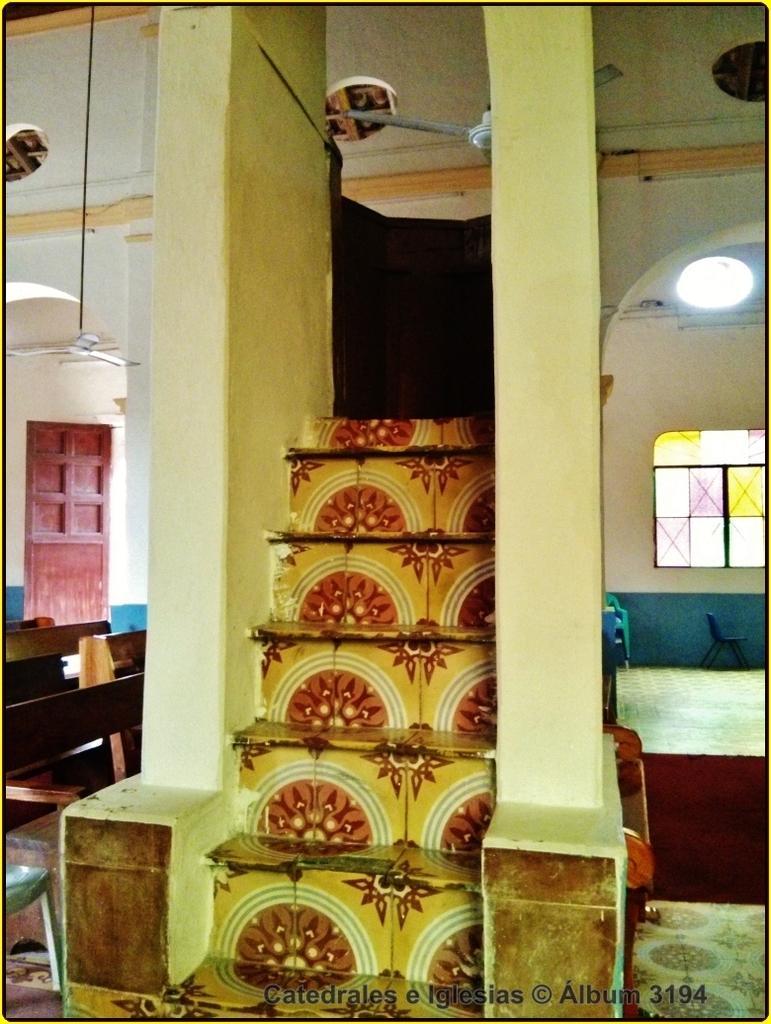Can you describe this image briefly? In this image we can see the interior of a room and we can see the steps with colorful paint. There are some benches and chairs. We can also see fans attached to the roof and there is a door and windows. 